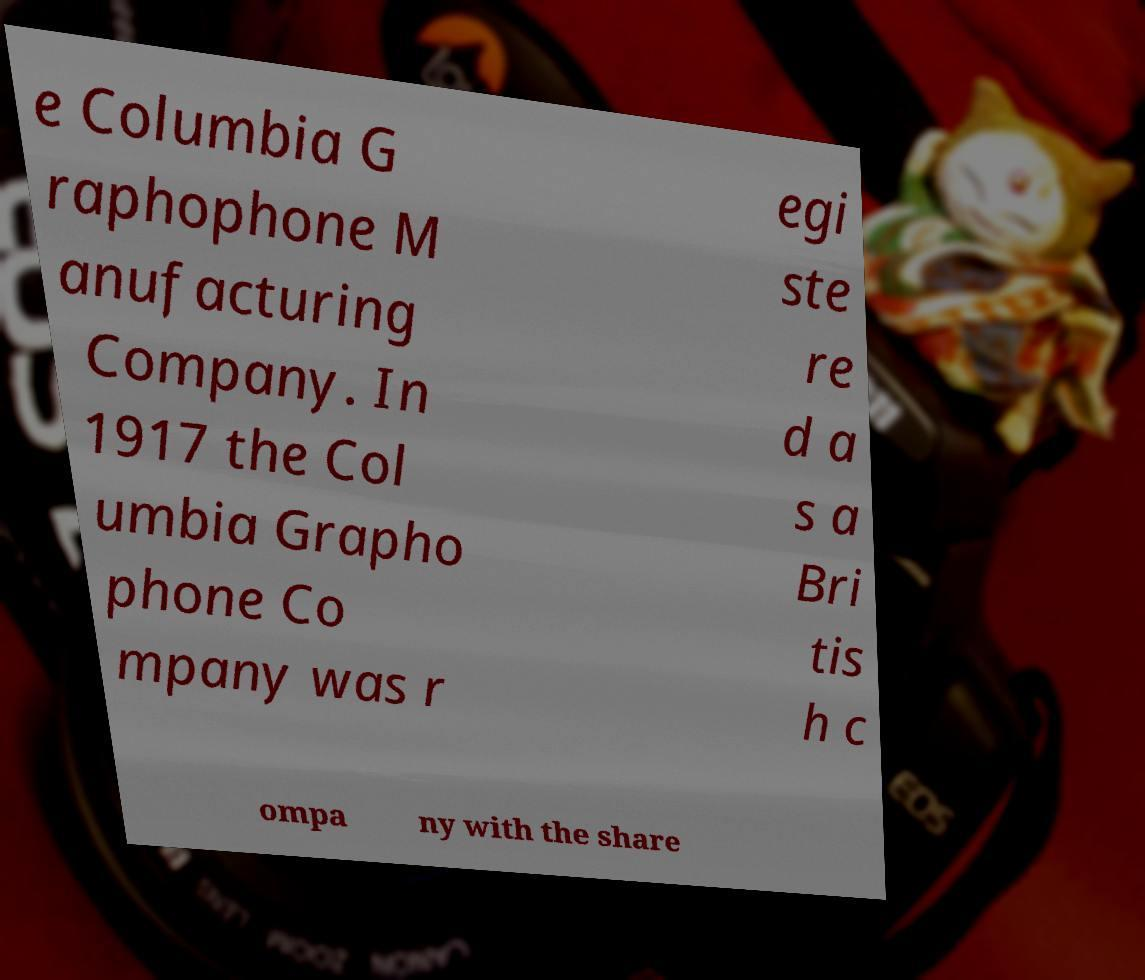Please read and relay the text visible in this image. What does it say? e Columbia G raphophone M anufacturing Company. In 1917 the Col umbia Grapho phone Co mpany was r egi ste re d a s a Bri tis h c ompa ny with the share 